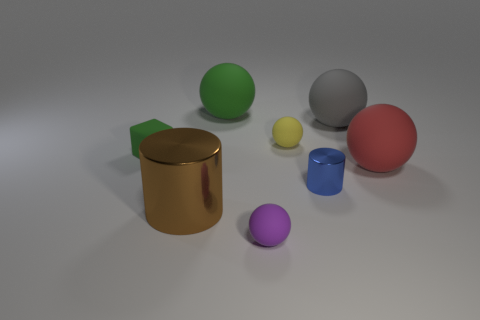The big cylinder has what color?
Give a very brief answer. Brown. What number of rubber blocks have the same color as the small metal cylinder?
Your response must be concise. 0. Are there any large green spheres behind the green sphere?
Provide a succinct answer. No. Are there an equal number of tiny rubber balls behind the tiny blue metal thing and tiny green rubber blocks in front of the large brown metal cylinder?
Your answer should be very brief. No. Does the ball that is in front of the large brown shiny cylinder have the same size as the metallic thing that is behind the big brown cylinder?
Offer a very short reply. Yes. What is the shape of the shiny thing left of the green thing on the right side of the big object that is on the left side of the big green rubber ball?
Keep it short and to the point. Cylinder. Is there any other thing that has the same material as the big green object?
Your answer should be compact. Yes. What size is the green thing that is the same shape as the gray object?
Your answer should be very brief. Large. There is a large rubber sphere that is on the right side of the small purple matte object and behind the red ball; what color is it?
Your response must be concise. Gray. Is the block made of the same material as the tiny ball behind the red matte object?
Keep it short and to the point. Yes. 